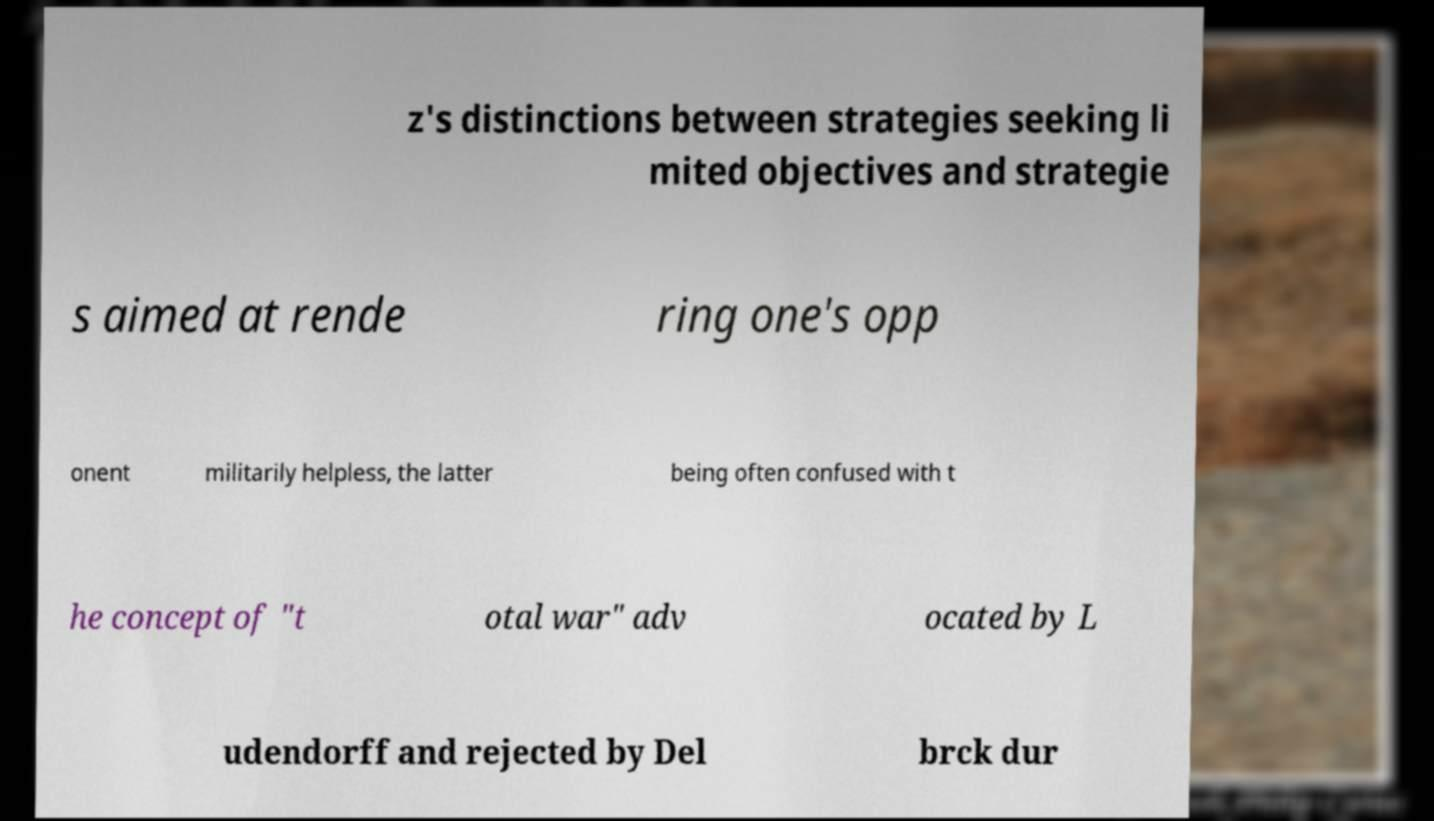Could you extract and type out the text from this image? z's distinctions between strategies seeking li mited objectives and strategie s aimed at rende ring one's opp onent militarily helpless, the latter being often confused with t he concept of "t otal war" adv ocated by L udendorff and rejected by Del brck dur 